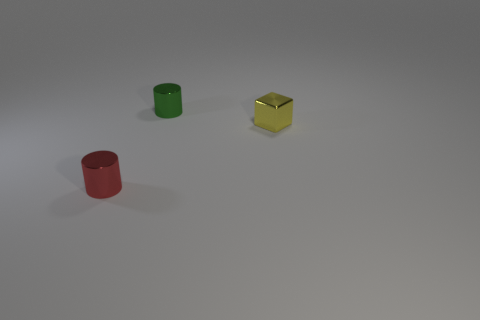Are there fewer cylinders in front of the yellow block than big balls?
Offer a very short reply. No. What number of green cylinders have the same size as the green object?
Keep it short and to the point. 0. There is a tiny metallic thing that is in front of the yellow block; what shape is it?
Your response must be concise. Cylinder. Are there fewer big gray matte blocks than tiny yellow metal objects?
Your response must be concise. Yes. Is there any other thing that has the same color as the tiny metal cube?
Keep it short and to the point. No. There is a object that is in front of the yellow block; what size is it?
Your response must be concise. Small. Are there more red metallic things than big red matte cubes?
Provide a short and direct response. Yes. What material is the small green cylinder?
Provide a short and direct response. Metal. What number of other things are there of the same material as the green thing
Your response must be concise. 2. How many small metal objects are there?
Keep it short and to the point. 3. 